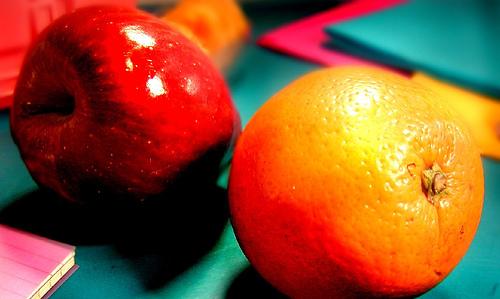What color is the table?
Give a very brief answer. Green. What is the red object on the left?
Be succinct. Apple. Which fruit can you peel with your hands?
Write a very short answer. Orange. 